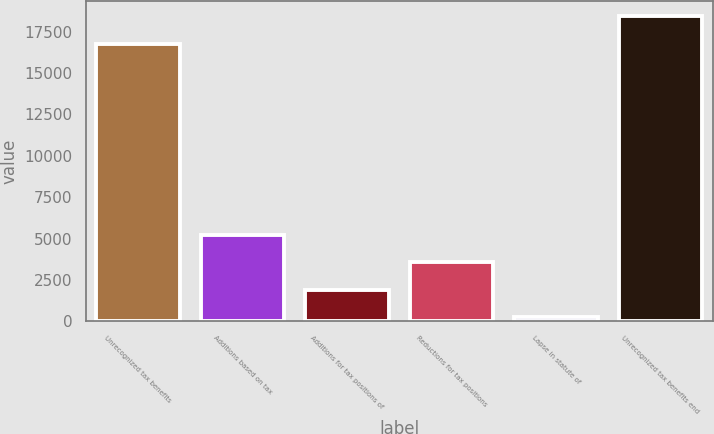<chart> <loc_0><loc_0><loc_500><loc_500><bar_chart><fcel>Unrecognized tax benefits<fcel>Additions based on tax<fcel>Additions for tax positions of<fcel>Reductions for tax positions<fcel>Lapse in statute of<fcel>Unrecognized tax benefits end<nl><fcel>16788<fcel>5235.7<fcel>1903.9<fcel>3569.8<fcel>238<fcel>18453.9<nl></chart> 